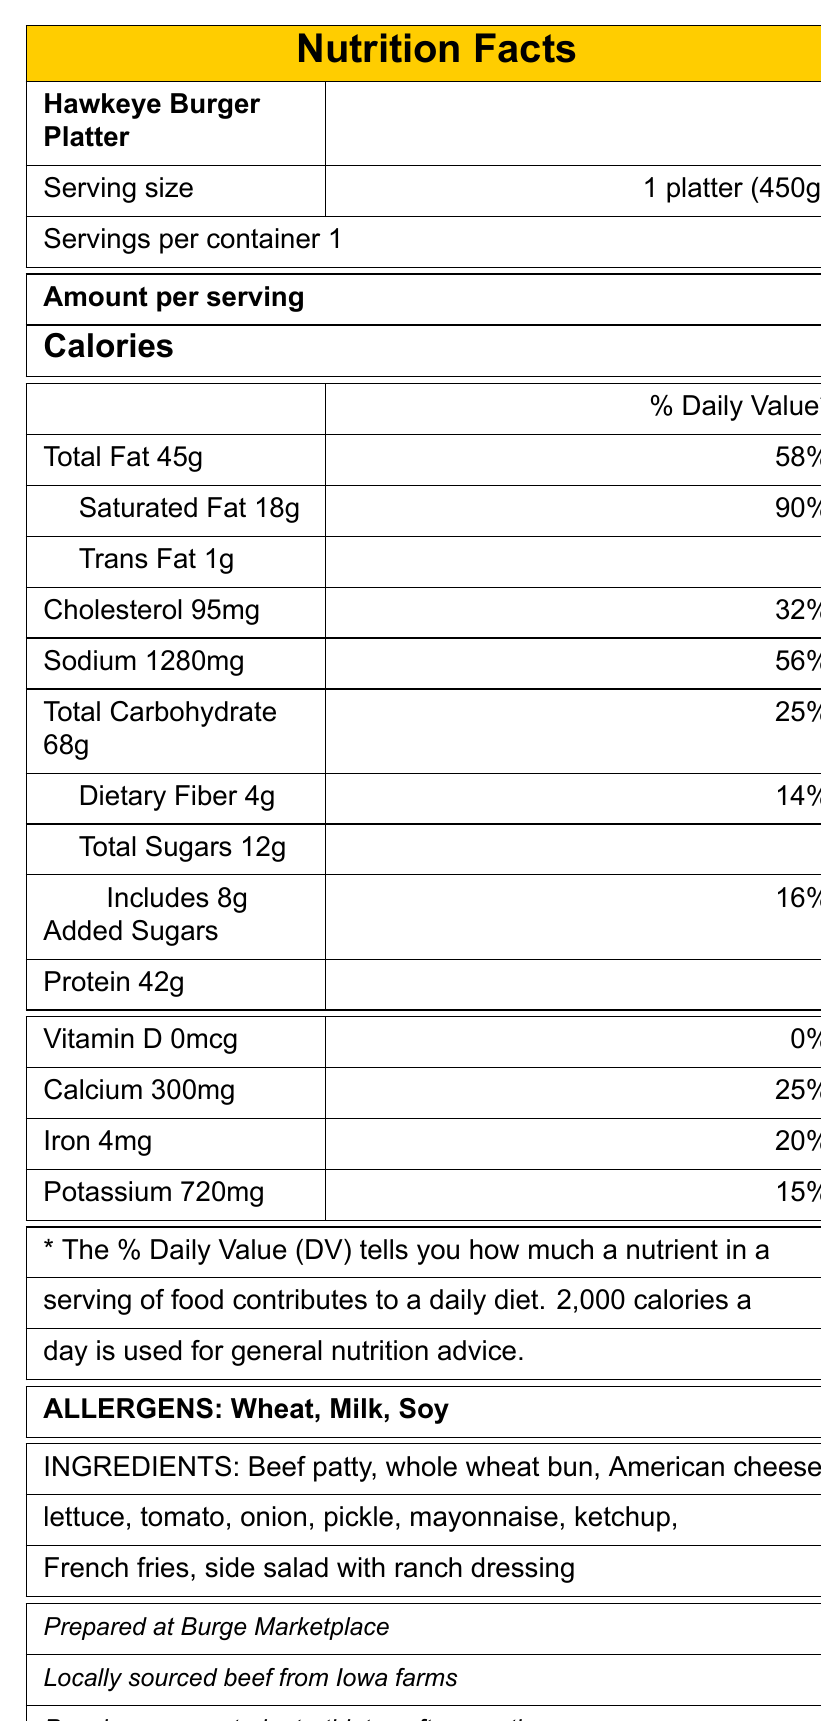what is the serving size of the Hawkeye Burger Platter? The serving size is listed at the top of the nutrition facts table as "1 platter (450g)".
Answer: 1 platter (450g) how many calories are in one serving of the Hawkeye Burger Platter? The document states that there are 850 calories per serving.
Answer: 850 what is the percentage daily value of saturated fat in the Hawkeye Burger Platter? The nutrition facts list the percentage daily value for saturated fat as 90%.
Answer: 90% which allergens are present in the Hawkeye Burger Platter? The allergens section lists Wheat, Milk, and Soy.
Answer: Wheat, Milk, Soy how much protein is in one serving of the Hawkeye Burger Platter? The document states there are 42 grams of protein per serving.
Answer: 42g how many milligrams of sodium does the Hawkeye Burger Platter contain? The sodium content is listed as 1280 milligrams.
Answer: 1280mg which nutrient has the highest percentage daily value? A. Total Fat B. Cholesterol C. Sodium D. Saturated Fat The percentage daily value for Saturated Fat is 90%, which is the highest among the listed nutrients.
Answer: D. Saturated Fat what is the preparation method for the sides included with the meal? 1. Steamed vegetables 2. Deep-fried French fries and side salad with ranch 3. Baked potato 4. Grilled vegetables The preparation method section specifies "Grilled burger, deep-fried fries".
Answer: 2. Deep-fried French fries and side salad with ranch is this meal suitable for vegetarians? The special diet info clearly states that the meal is not suitable for vegetarians or vegans.
Answer: No summarize the main nutritional details of the Hawkeye Burger Platter. This summary includes the key nutritional components of the meal as described in the document.
Answer: The Hawkeye Burger Platter contains 850 calories per serving, with 45g of total fat, 18g of saturated fat, and 1280mg of sodium. It also has 68g of total carbohydrates, 4g of dietary fiber, and 42g of protein. The main allergens are Wheat, Milk, and Soy. what is the exact source of the beef used in the Hawkeye Burger Platter? The document mentions that the beef is locally sourced from Iowa farms, but it does not specify the exact source.
Answer: Cannot be determined 